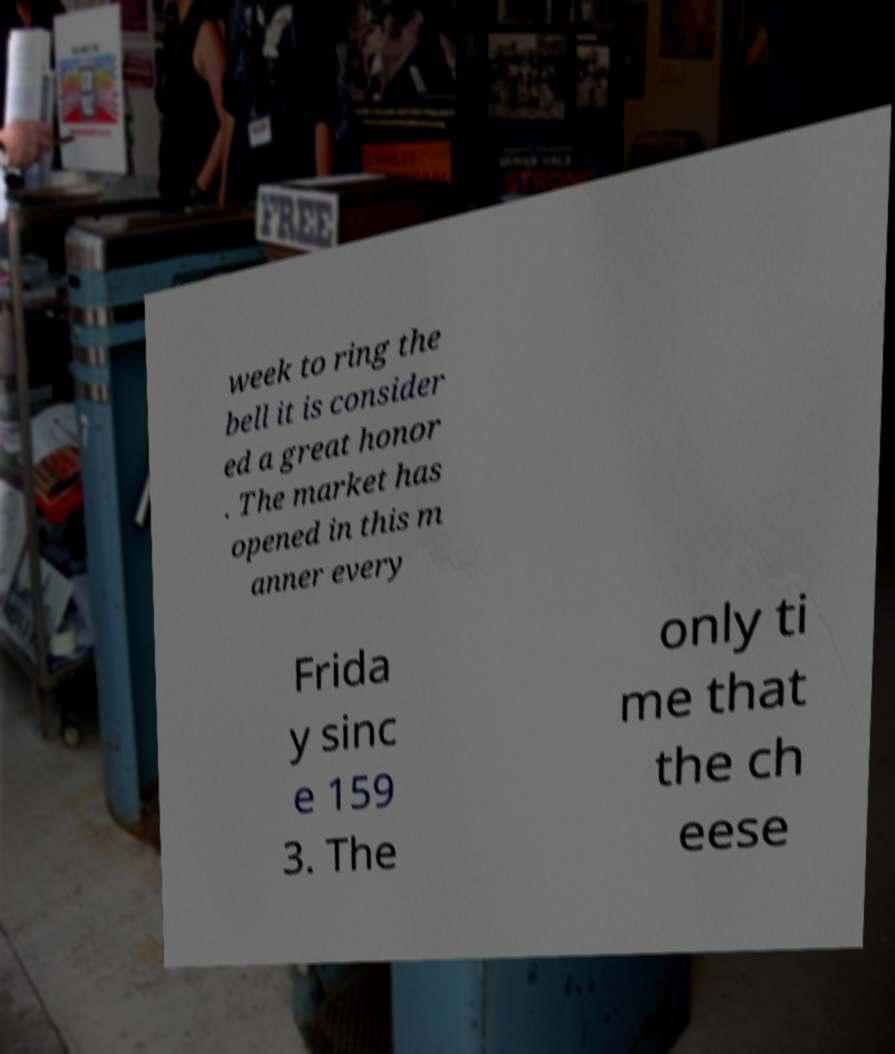Please read and relay the text visible in this image. What does it say? week to ring the bell it is consider ed a great honor . The market has opened in this m anner every Frida y sinc e 159 3. The only ti me that the ch eese 